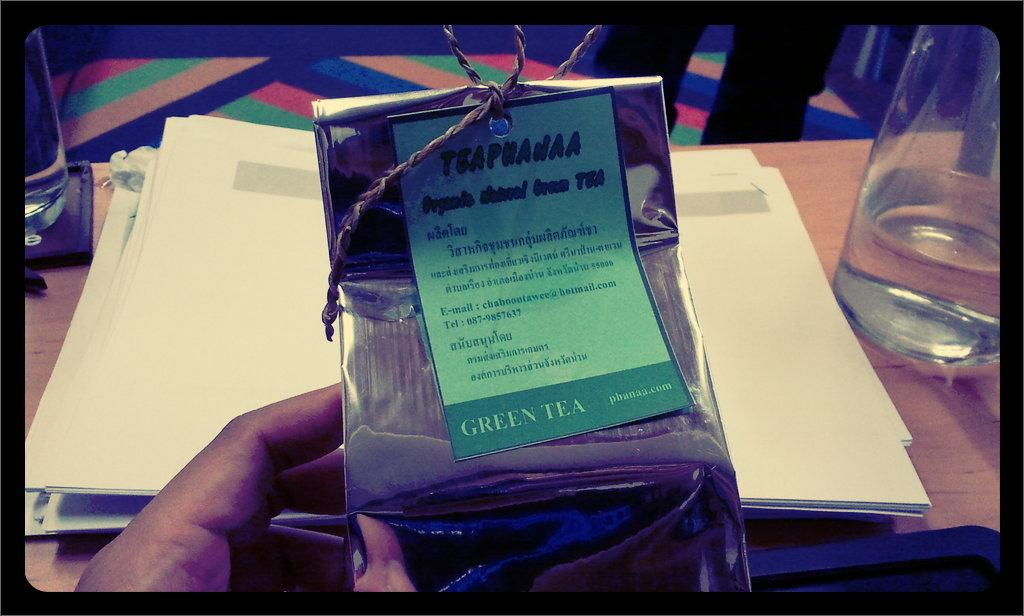<image>
Relay a brief, clear account of the picture shown. A person holding a package of Green Tea. 